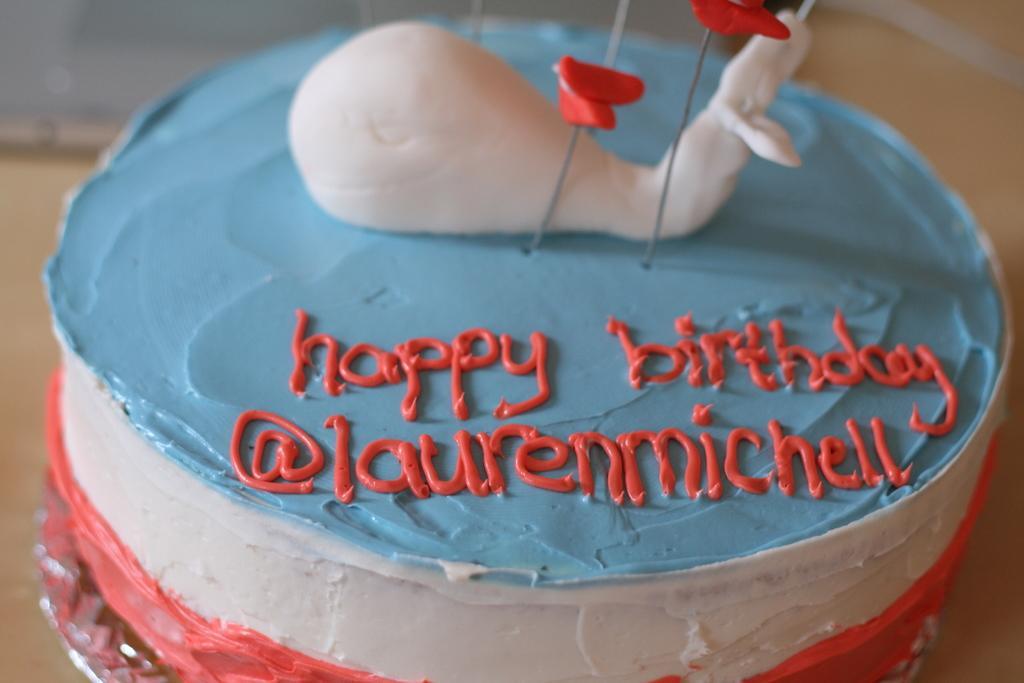Describe this image in one or two sentences. In this picture we can see colorful cake on the platform. In the background of the image it is blurry. 